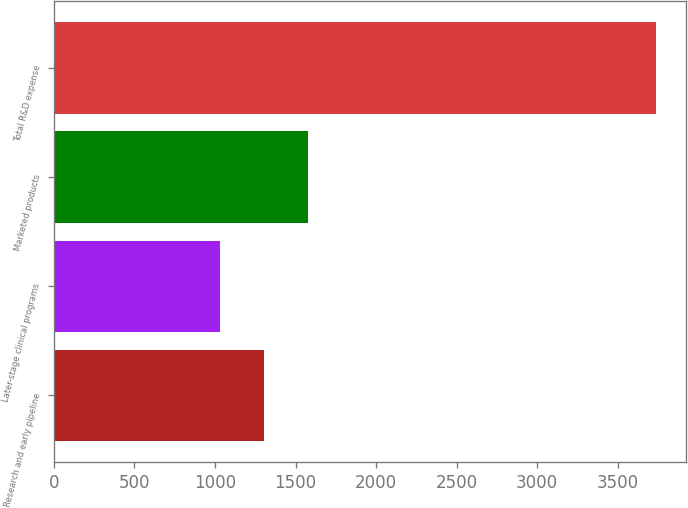Convert chart to OTSL. <chart><loc_0><loc_0><loc_500><loc_500><bar_chart><fcel>Research and early pipeline<fcel>Later-stage clinical programs<fcel>Marketed products<fcel>Total R&D expense<nl><fcel>1304.3<fcel>1034<fcel>1574.6<fcel>3737<nl></chart> 